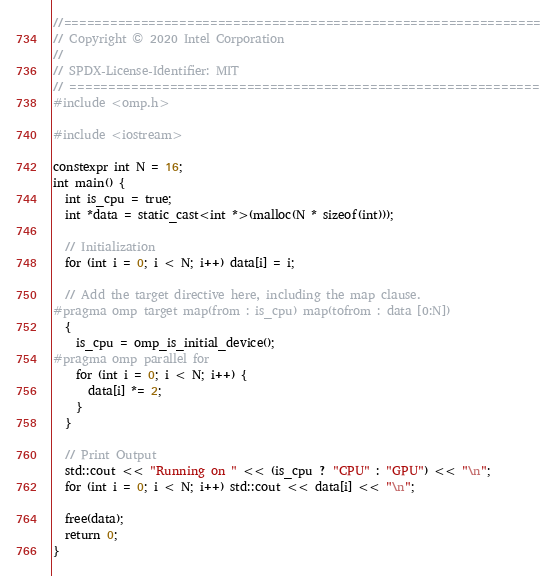Convert code to text. <code><loc_0><loc_0><loc_500><loc_500><_C++_>//==============================================================
// Copyright © 2020 Intel Corporation
//
// SPDX-License-Identifier: MIT
// =============================================================
#include <omp.h>

#include <iostream>

constexpr int N = 16;
int main() {
  int is_cpu = true;
  int *data = static_cast<int *>(malloc(N * sizeof(int)));

  // Initialization
  for (int i = 0; i < N; i++) data[i] = i;

  // Add the target directive here, including the map clause.
#pragma omp target map(from : is_cpu) map(tofrom : data [0:N])
  {
    is_cpu = omp_is_initial_device();
#pragma omp parallel for
    for (int i = 0; i < N; i++) {
      data[i] *= 2;
    }
  }

  // Print Output
  std::cout << "Running on " << (is_cpu ? "CPU" : "GPU") << "\n";
  for (int i = 0; i < N; i++) std::cout << data[i] << "\n";

  free(data);
  return 0;
}
</code> 